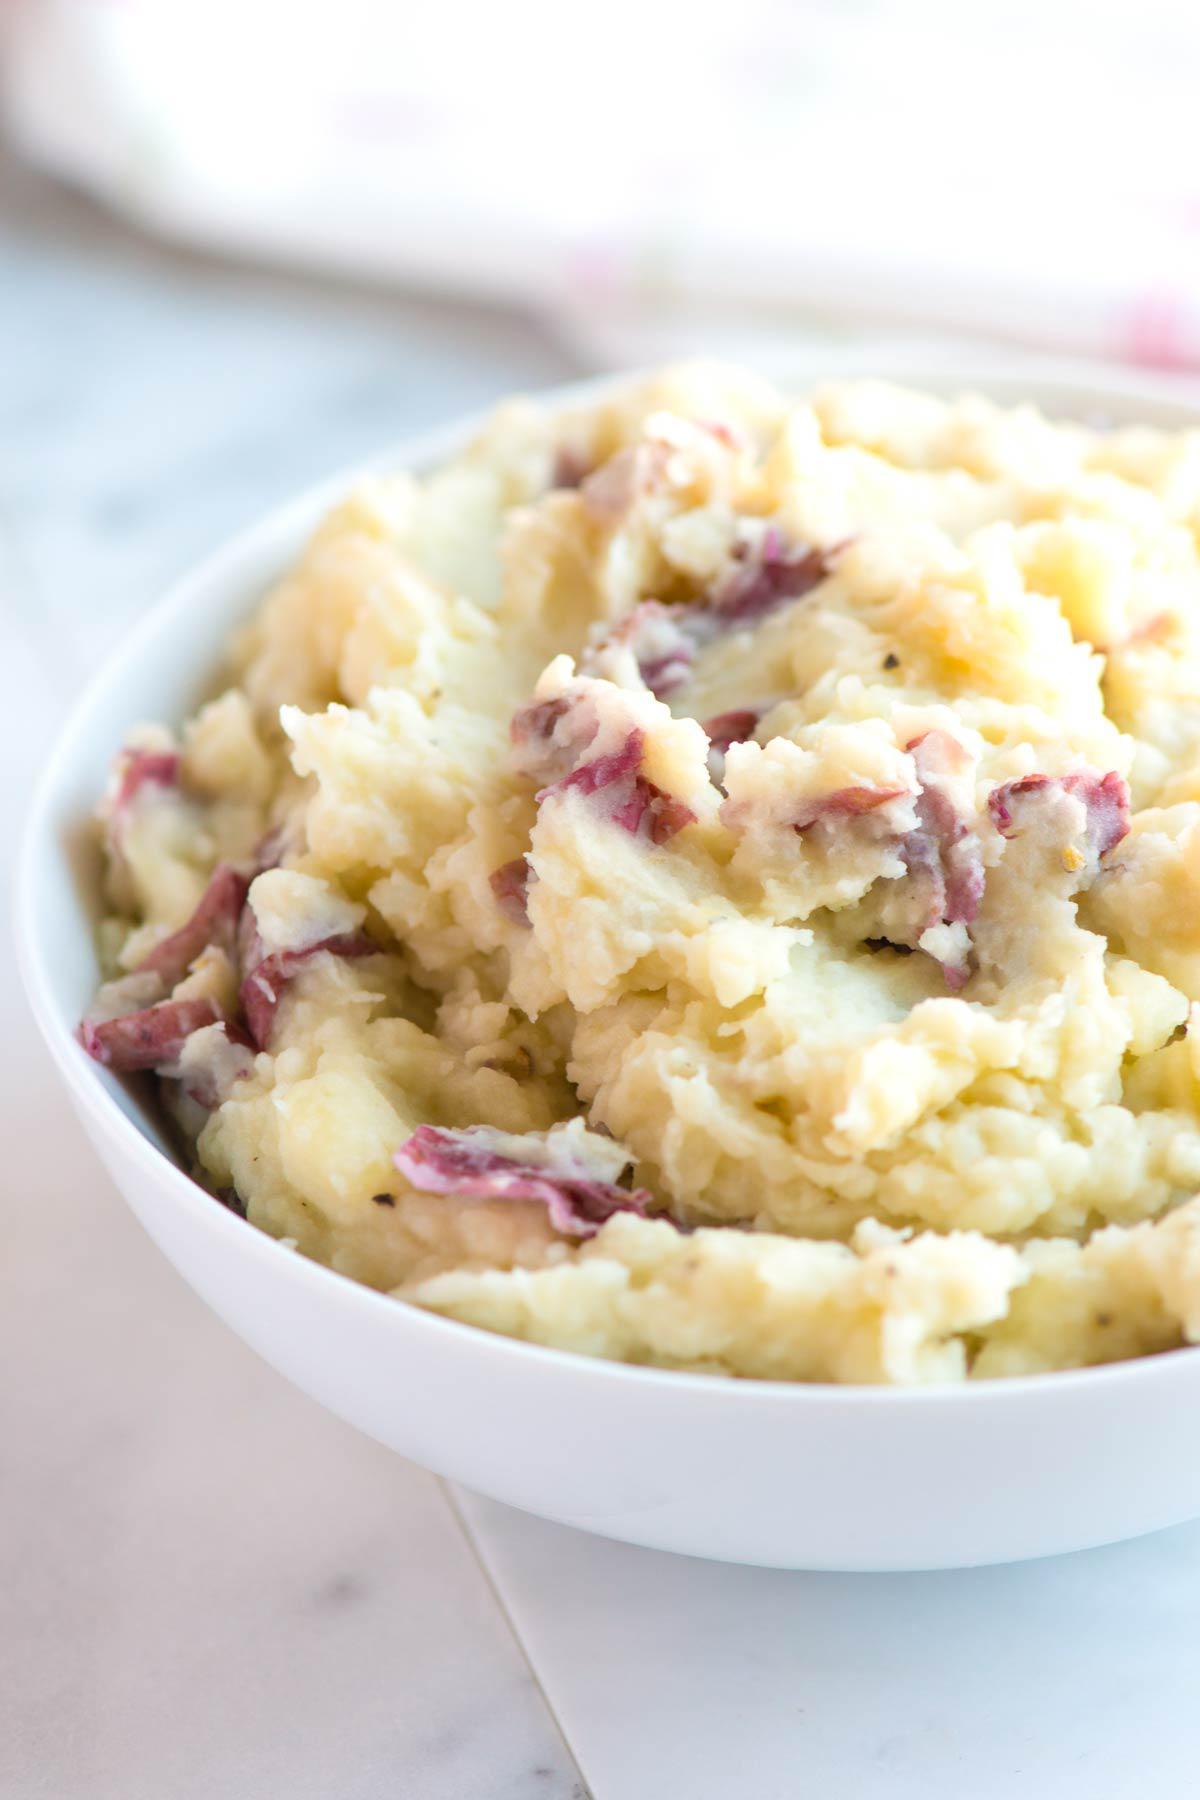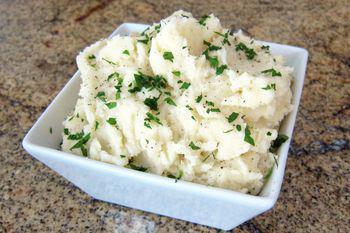The first image is the image on the left, the second image is the image on the right. Considering the images on both sides, is "One image shows mashed potatoes in a squared white dish, with no other food served on the same dish." valid? Answer yes or no. Yes. The first image is the image on the left, the second image is the image on the right. For the images shown, is this caption "One of the images shows  a bowl of mashed potatoes with a spoon in it." true? Answer yes or no. No. 